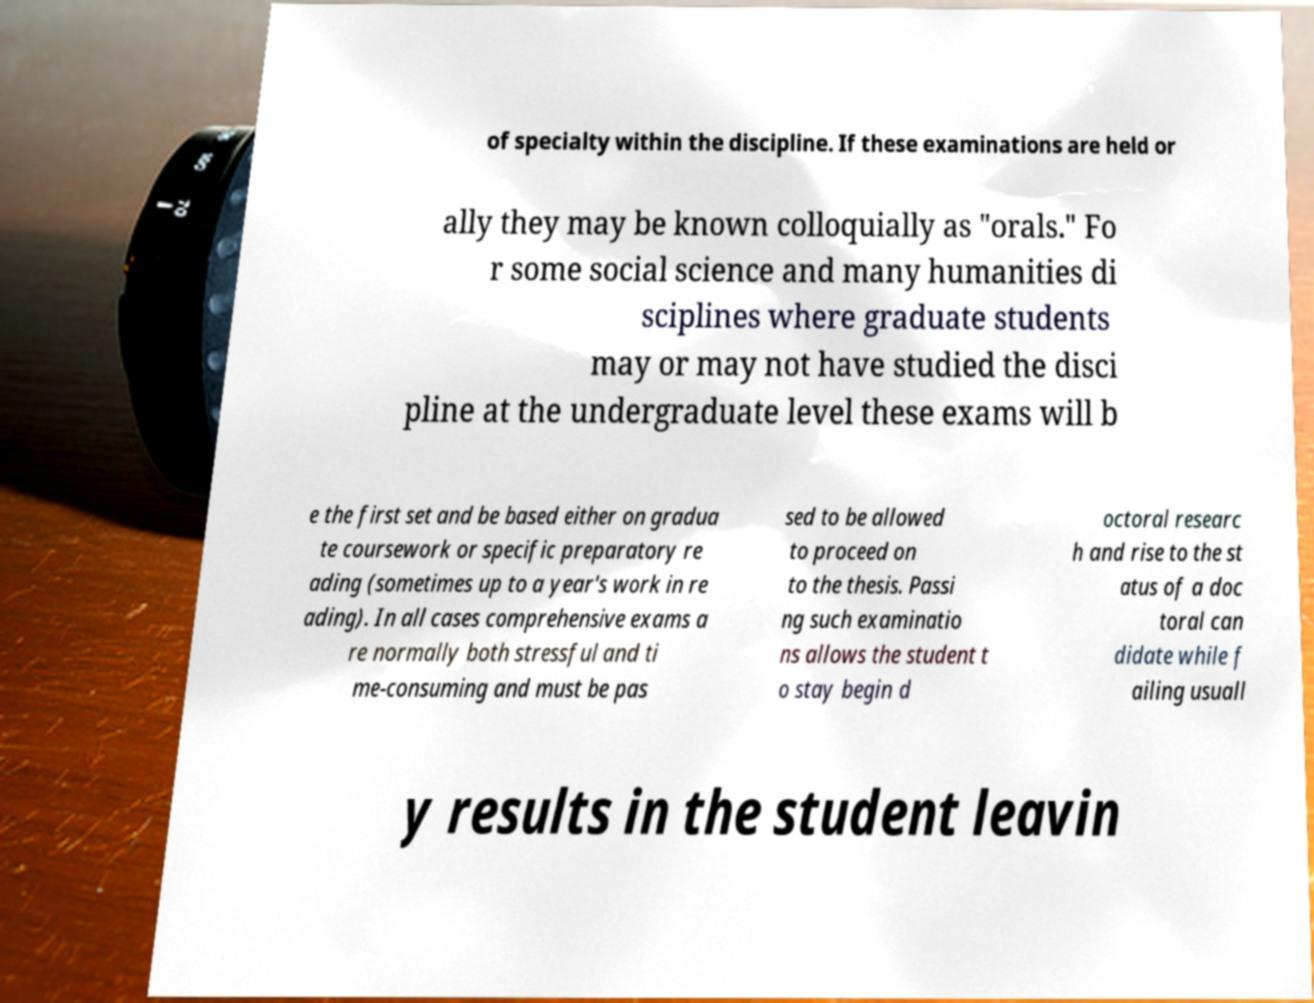Please read and relay the text visible in this image. What does it say? of specialty within the discipline. If these examinations are held or ally they may be known colloquially as "orals." Fo r some social science and many humanities di sciplines where graduate students may or may not have studied the disci pline at the undergraduate level these exams will b e the first set and be based either on gradua te coursework or specific preparatory re ading (sometimes up to a year's work in re ading). In all cases comprehensive exams a re normally both stressful and ti me-consuming and must be pas sed to be allowed to proceed on to the thesis. Passi ng such examinatio ns allows the student t o stay begin d octoral researc h and rise to the st atus of a doc toral can didate while f ailing usuall y results in the student leavin 